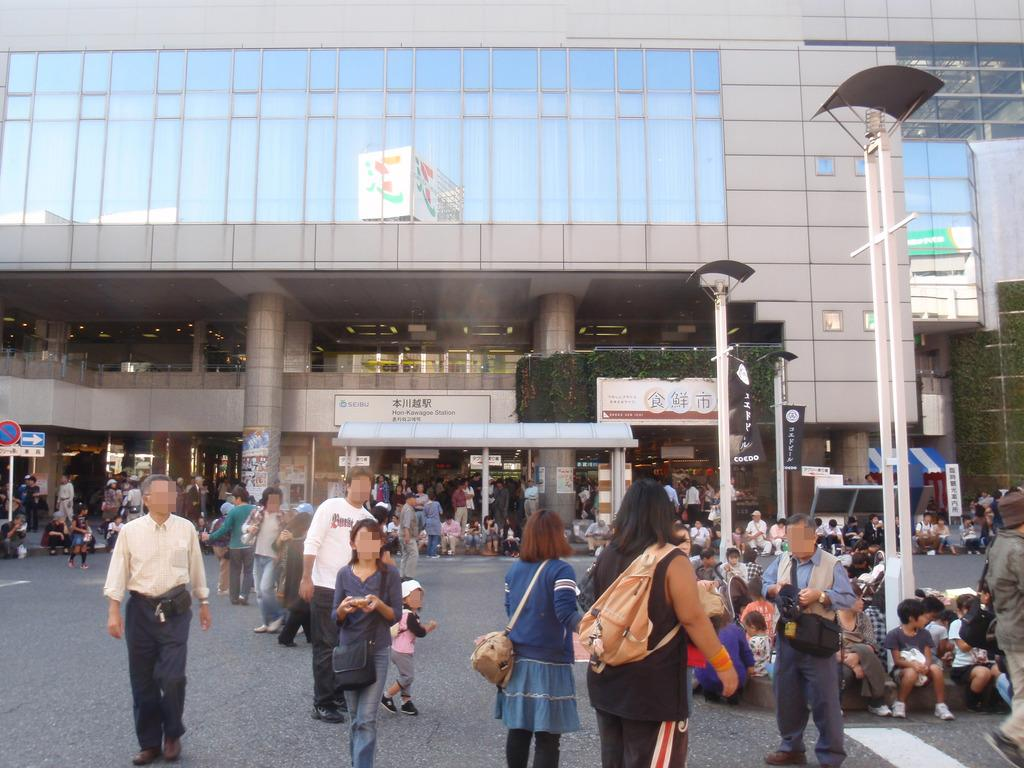What is the main subject in the center of the image? There is a building in the center of the image. Can you describe the people at the bottom side of the image? There are people at the bottom side of the image, but their specific actions or characteristics are not mentioned in the facts. What type of view does the image provide? The image appears to be a roadside view. What brand of toothpaste is being advertised on the building in the image? There is no toothpaste or advertisement mentioned in the image, so it cannot be determined from the image. 